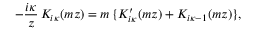<formula> <loc_0><loc_0><loc_500><loc_500>- \frac { i \kappa } { z } \, K _ { i \kappa } ( m z ) = m \, \{ K _ { i \kappa } ^ { \prime } ( m z ) + K _ { i \kappa - 1 } ( m z ) \} ,</formula> 